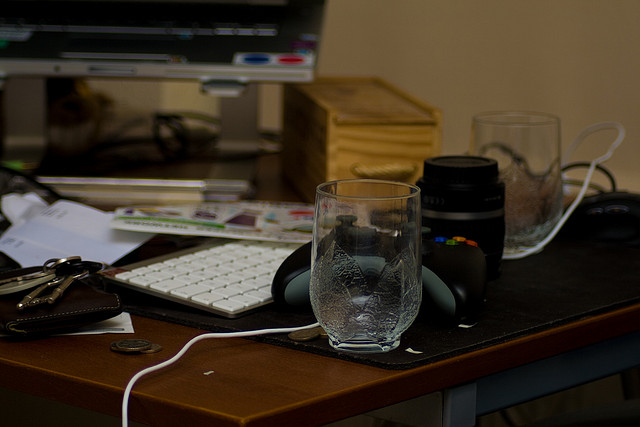<image>What is the beverage in the mug? There is no beverage in the mug. However, it could possibly be water. What is the beverage in the mug? It can be seen that the beverage in the mug is either water or coffee. 